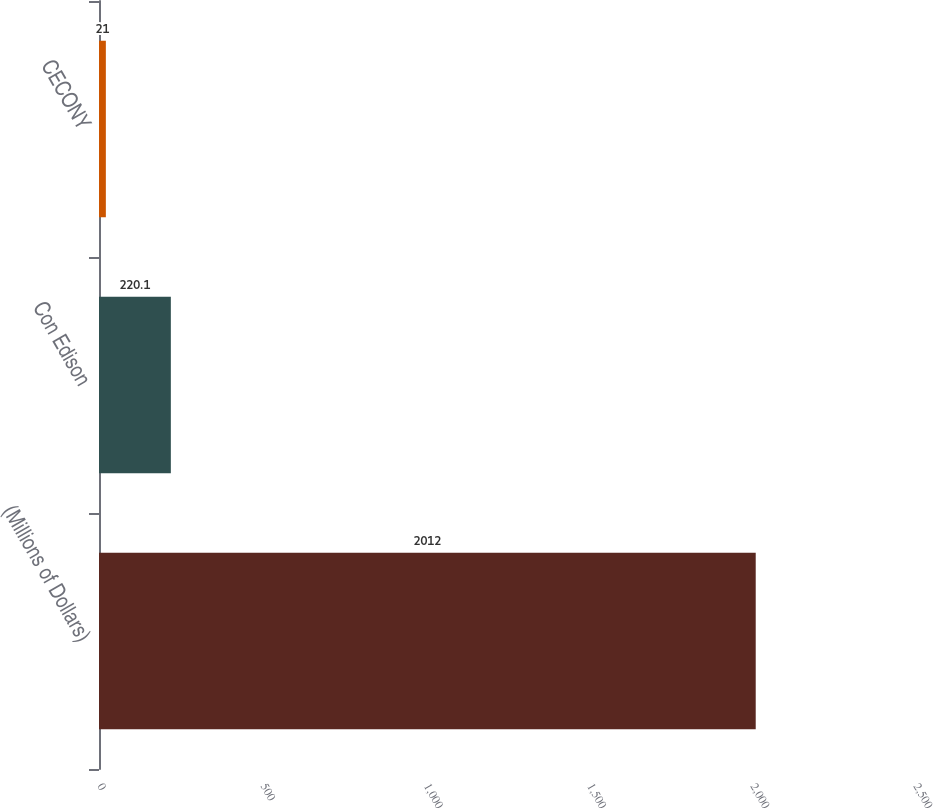Convert chart. <chart><loc_0><loc_0><loc_500><loc_500><bar_chart><fcel>(Millions of Dollars)<fcel>Con Edison<fcel>CECONY<nl><fcel>2012<fcel>220.1<fcel>21<nl></chart> 